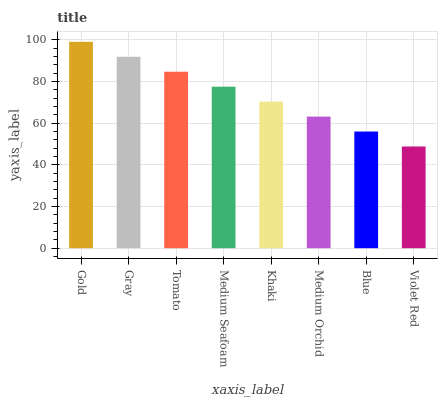Is Violet Red the minimum?
Answer yes or no. Yes. Is Gold the maximum?
Answer yes or no. Yes. Is Gray the minimum?
Answer yes or no. No. Is Gray the maximum?
Answer yes or no. No. Is Gold greater than Gray?
Answer yes or no. Yes. Is Gray less than Gold?
Answer yes or no. Yes. Is Gray greater than Gold?
Answer yes or no. No. Is Gold less than Gray?
Answer yes or no. No. Is Medium Seafoam the high median?
Answer yes or no. Yes. Is Khaki the low median?
Answer yes or no. Yes. Is Tomato the high median?
Answer yes or no. No. Is Violet Red the low median?
Answer yes or no. No. 